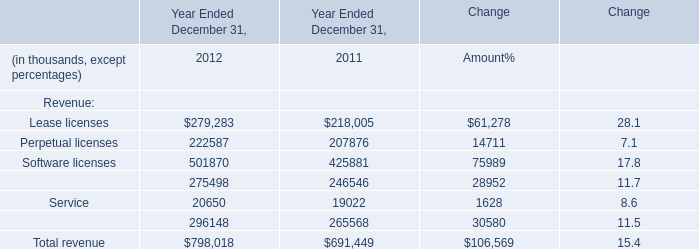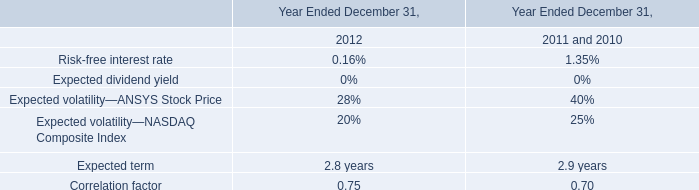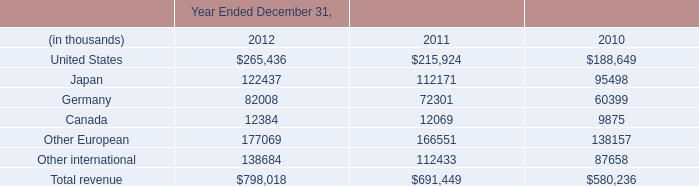what's the total amount of Canada of Year Ended December 31, 2010, and Lease licenses of Year Ended December 31, 2011 ? 
Computations: (9875.0 + 218005.0)
Answer: 227880.0. 